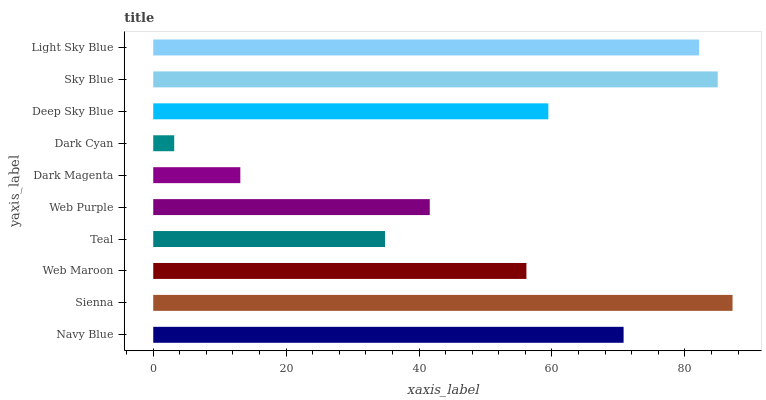Is Dark Cyan the minimum?
Answer yes or no. Yes. Is Sienna the maximum?
Answer yes or no. Yes. Is Web Maroon the minimum?
Answer yes or no. No. Is Web Maroon the maximum?
Answer yes or no. No. Is Sienna greater than Web Maroon?
Answer yes or no. Yes. Is Web Maroon less than Sienna?
Answer yes or no. Yes. Is Web Maroon greater than Sienna?
Answer yes or no. No. Is Sienna less than Web Maroon?
Answer yes or no. No. Is Deep Sky Blue the high median?
Answer yes or no. Yes. Is Web Maroon the low median?
Answer yes or no. Yes. Is Sky Blue the high median?
Answer yes or no. No. Is Sienna the low median?
Answer yes or no. No. 